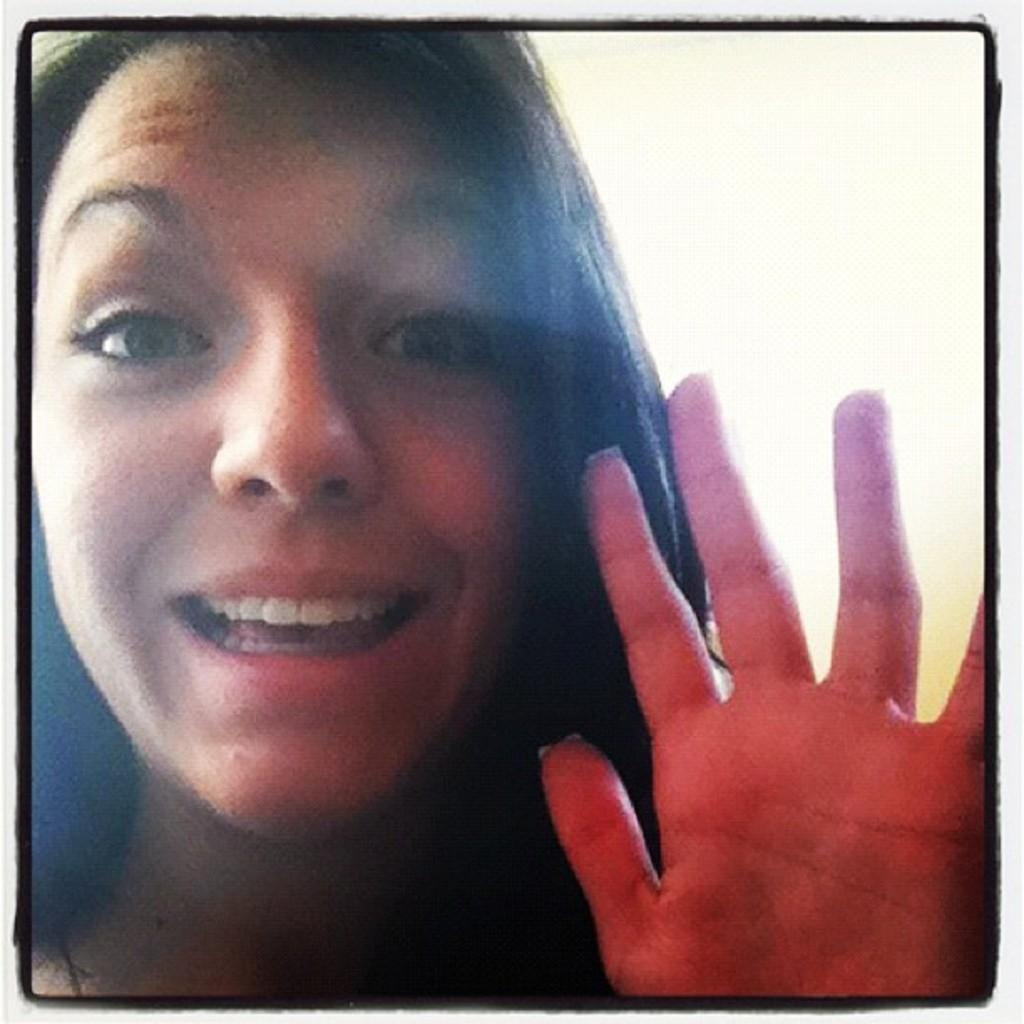Who is present in the image? There is a lady in the image. What type of dinosaurs can be seen in the image? There are no dinosaurs present in the image; it features a lady. What is the lady's belief about the existence of dinosaurs in the image? The image does not provide any information about the lady's beliefs, including her beliefs about dinosaurs. 